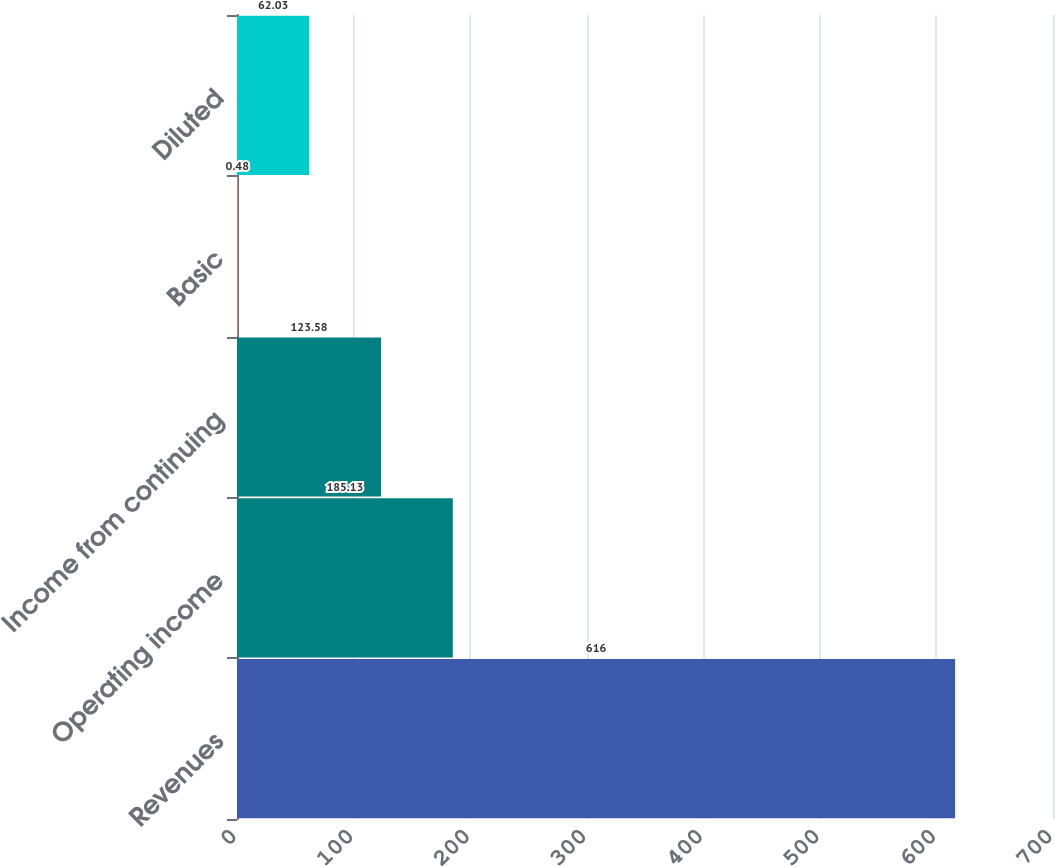Convert chart to OTSL. <chart><loc_0><loc_0><loc_500><loc_500><bar_chart><fcel>Revenues<fcel>Operating income<fcel>Income from continuing<fcel>Basic<fcel>Diluted<nl><fcel>616<fcel>185.13<fcel>123.58<fcel>0.48<fcel>62.03<nl></chart> 